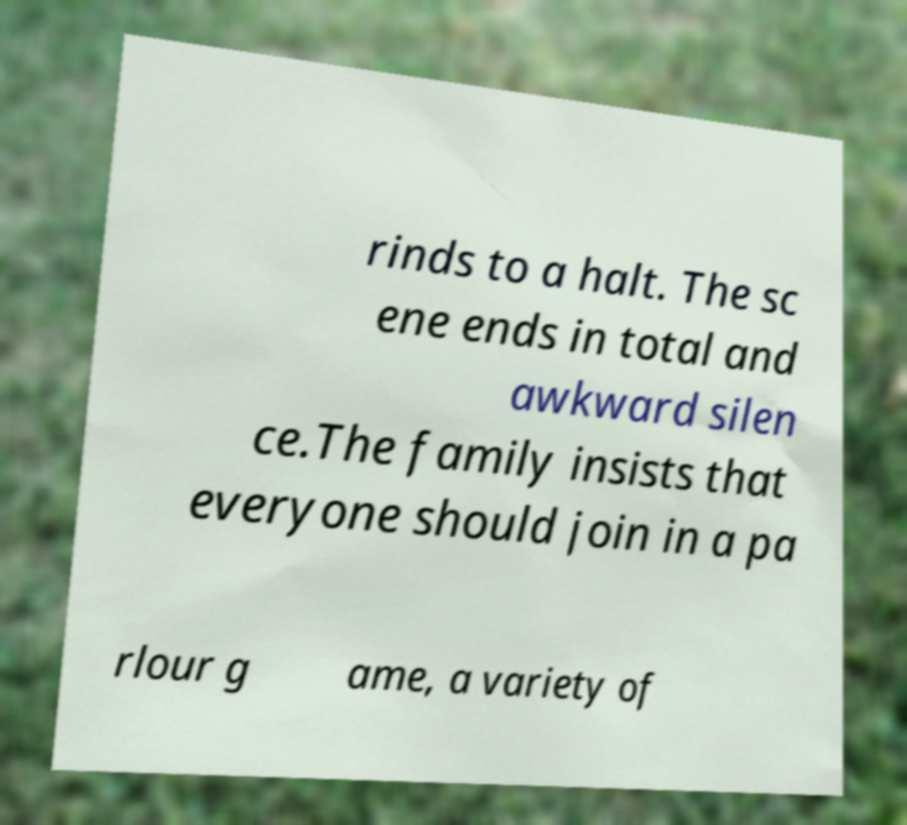What messages or text are displayed in this image? I need them in a readable, typed format. rinds to a halt. The sc ene ends in total and awkward silen ce.The family insists that everyone should join in a pa rlour g ame, a variety of 